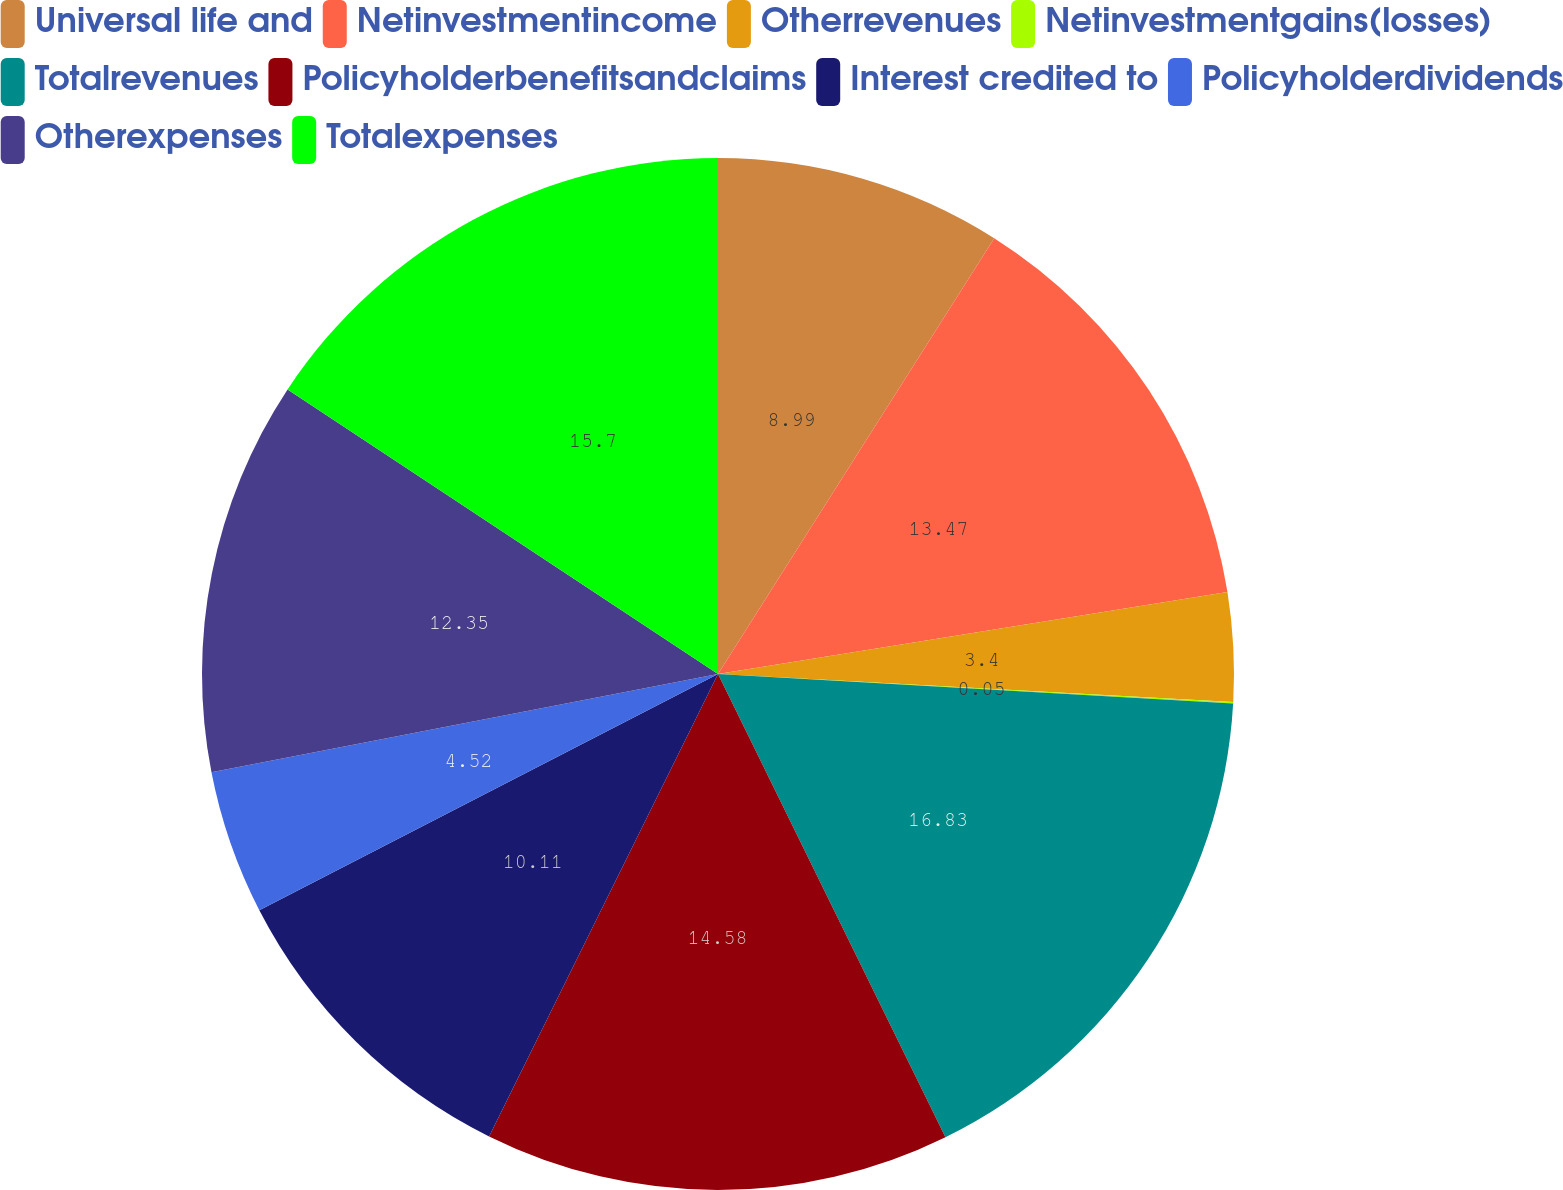<chart> <loc_0><loc_0><loc_500><loc_500><pie_chart><fcel>Universal life and<fcel>Netinvestmentincome<fcel>Otherrevenues<fcel>Netinvestmentgains(losses)<fcel>Totalrevenues<fcel>Policyholderbenefitsandclaims<fcel>Interest credited to<fcel>Policyholderdividends<fcel>Otherexpenses<fcel>Totalexpenses<nl><fcel>8.99%<fcel>13.47%<fcel>3.4%<fcel>0.05%<fcel>16.82%<fcel>14.58%<fcel>10.11%<fcel>4.52%<fcel>12.35%<fcel>15.7%<nl></chart> 